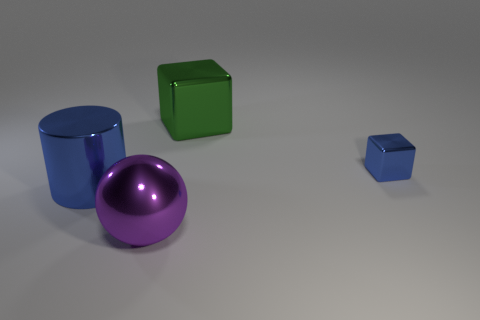Is there anything else that has the same size as the blue metallic block?
Your answer should be compact. No. What material is the tiny object that is the same color as the cylinder?
Make the answer very short. Metal. There is a cube that is the same color as the large cylinder; what size is it?
Give a very brief answer. Small. Is there a green object of the same size as the purple ball?
Provide a succinct answer. Yes. Are the big object that is behind the small blue thing and the cylinder made of the same material?
Make the answer very short. Yes. Are there the same number of green objects that are in front of the green shiny cube and shiny spheres behind the small block?
Offer a terse response. Yes. There is a object that is both to the right of the purple metallic thing and to the left of the tiny metal thing; what is its shape?
Ensure brevity in your answer.  Cube. There is a tiny blue cube; how many shiny blocks are behind it?
Make the answer very short. 1. How many other things are there of the same shape as the large green metallic thing?
Make the answer very short. 1. Are there fewer blue metal things than metal objects?
Your response must be concise. Yes. 